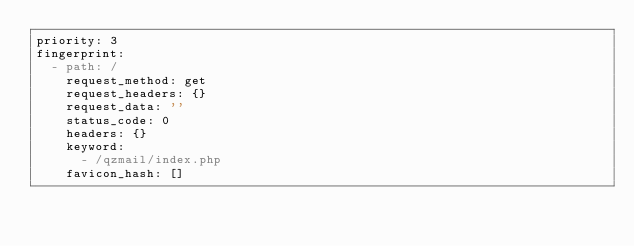<code> <loc_0><loc_0><loc_500><loc_500><_YAML_>priority: 3
fingerprint:
  - path: /
    request_method: get
    request_headers: {}
    request_data: ''
    status_code: 0
    headers: {}
    keyword:
      - /qzmail/index.php
    favicon_hash: []
</code> 